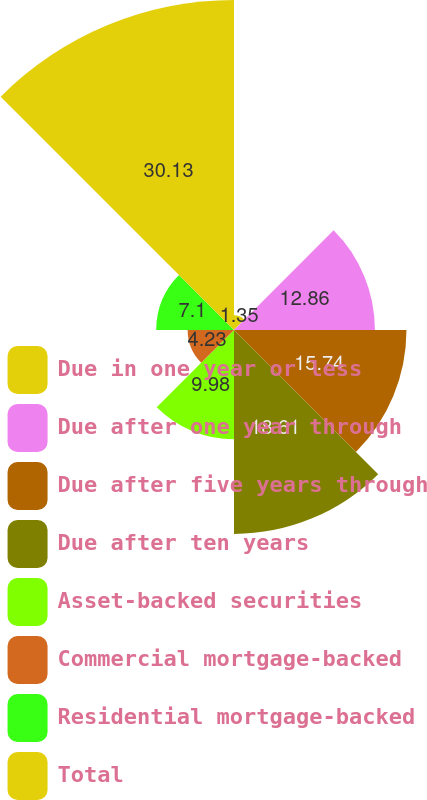Convert chart. <chart><loc_0><loc_0><loc_500><loc_500><pie_chart><fcel>Due in one year or less<fcel>Due after one year through<fcel>Due after five years through<fcel>Due after ten years<fcel>Asset-backed securities<fcel>Commercial mortgage-backed<fcel>Residential mortgage-backed<fcel>Total<nl><fcel>1.35%<fcel>12.86%<fcel>15.74%<fcel>18.61%<fcel>9.98%<fcel>4.23%<fcel>7.1%<fcel>30.12%<nl></chart> 